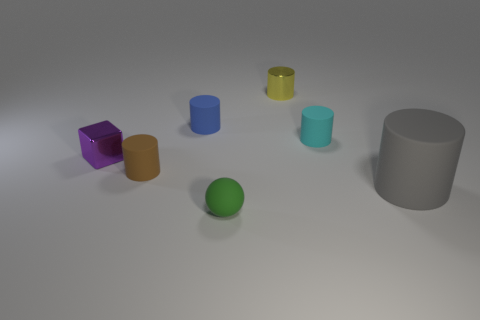How big is the yellow metal cylinder on the left side of the tiny rubber cylinder right of the green matte object?
Your response must be concise. Small. There is a green object that is the same size as the cyan rubber thing; what is its material?
Provide a succinct answer. Rubber. How many other things are the same size as the purple object?
Offer a very short reply. 5. How many blocks are small yellow metallic things or blue things?
Keep it short and to the point. 0. There is a thing that is right of the small matte cylinder on the right side of the metallic object that is behind the blue rubber thing; what is it made of?
Your response must be concise. Rubber. What number of gray cylinders have the same material as the small blue object?
Your answer should be very brief. 1. There is a metal thing that is to the left of the metal cylinder; is its size the same as the tiny yellow cylinder?
Give a very brief answer. Yes. What is the color of the ball that is the same material as the blue thing?
Your answer should be very brief. Green. Is there anything else that has the same size as the blue rubber thing?
Provide a short and direct response. Yes. What number of small matte cylinders are behind the small purple metallic thing?
Provide a short and direct response. 2. 